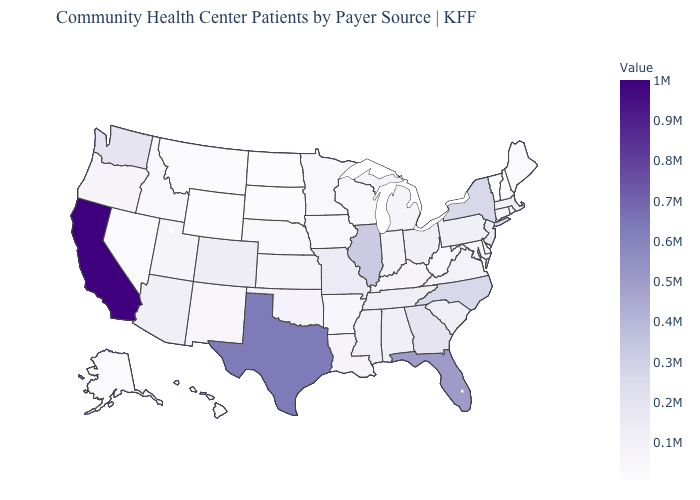Which states have the lowest value in the MidWest?
Give a very brief answer. North Dakota. Does California have the highest value in the West?
Keep it brief. Yes. Does New Jersey have a lower value than Nevada?
Be succinct. No. Does Arizona have a higher value than Wyoming?
Concise answer only. Yes. Does California have the highest value in the West?
Give a very brief answer. Yes. 